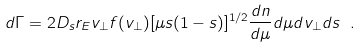<formula> <loc_0><loc_0><loc_500><loc_500>d \Gamma = 2 D _ { s } r _ { E } v _ { \perp } f ( v _ { \perp } ) [ \mu s ( 1 - s ) ] ^ { 1 / 2 } \frac { d n } { d \mu } d \mu d v _ { \perp } d s \ .</formula> 